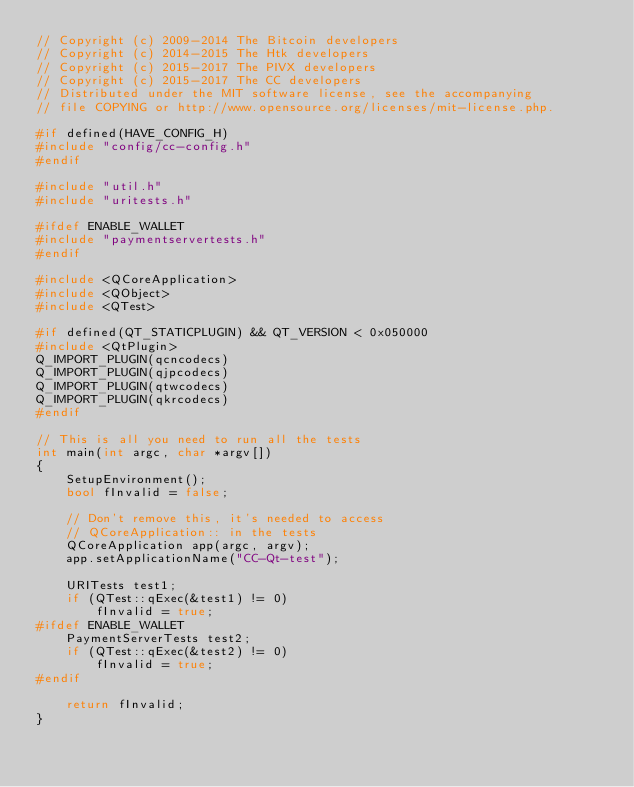Convert code to text. <code><loc_0><loc_0><loc_500><loc_500><_C++_>// Copyright (c) 2009-2014 The Bitcoin developers
// Copyright (c) 2014-2015 The Htk developers
// Copyright (c) 2015-2017 The PIVX developers 
// Copyright (c) 2015-2017 The CC developers
// Distributed under the MIT software license, see the accompanying
// file COPYING or http://www.opensource.org/licenses/mit-license.php.

#if defined(HAVE_CONFIG_H)
#include "config/cc-config.h"
#endif

#include "util.h"
#include "uritests.h"

#ifdef ENABLE_WALLET
#include "paymentservertests.h"
#endif

#include <QCoreApplication>
#include <QObject>
#include <QTest>

#if defined(QT_STATICPLUGIN) && QT_VERSION < 0x050000
#include <QtPlugin>
Q_IMPORT_PLUGIN(qcncodecs)
Q_IMPORT_PLUGIN(qjpcodecs)
Q_IMPORT_PLUGIN(qtwcodecs)
Q_IMPORT_PLUGIN(qkrcodecs)
#endif

// This is all you need to run all the tests
int main(int argc, char *argv[])
{
    SetupEnvironment();
    bool fInvalid = false;

    // Don't remove this, it's needed to access
    // QCoreApplication:: in the tests
    QCoreApplication app(argc, argv);
    app.setApplicationName("CC-Qt-test");

    URITests test1;
    if (QTest::qExec(&test1) != 0)
        fInvalid = true;
#ifdef ENABLE_WALLET
    PaymentServerTests test2;
    if (QTest::qExec(&test2) != 0)
        fInvalid = true;
#endif

    return fInvalid;
}
</code> 